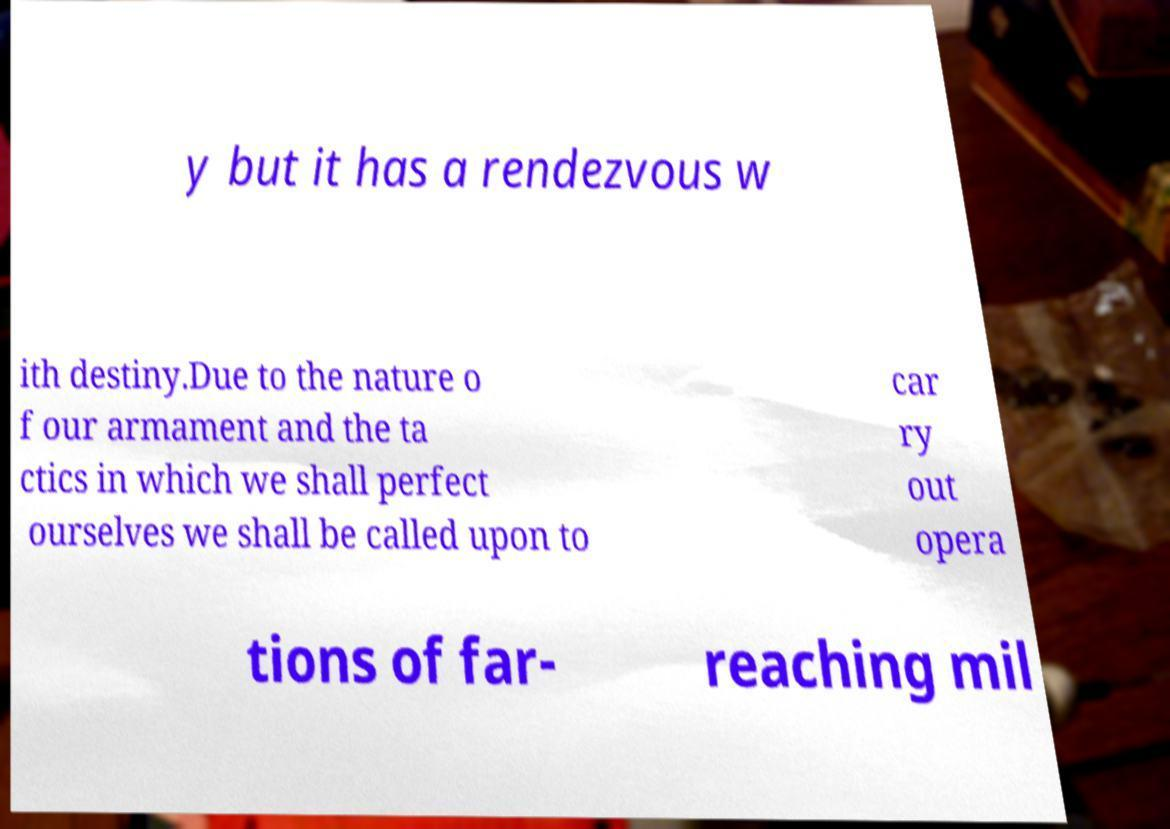Please identify and transcribe the text found in this image. y but it has a rendezvous w ith destiny.Due to the nature o f our armament and the ta ctics in which we shall perfect ourselves we shall be called upon to car ry out opera tions of far- reaching mil 